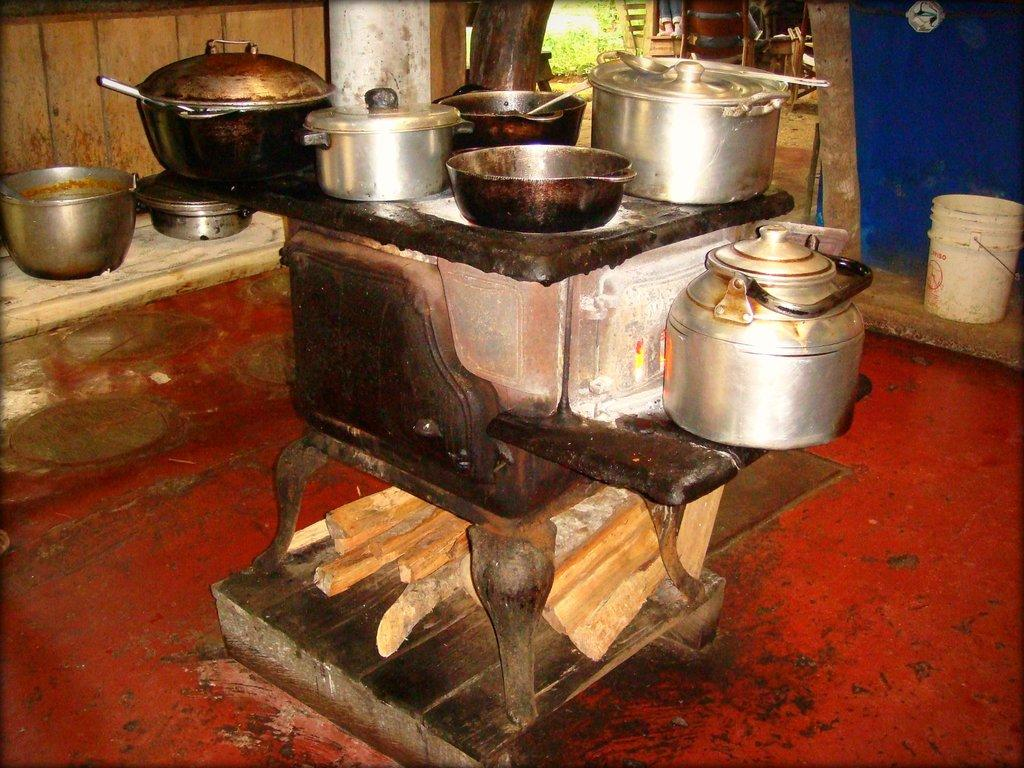What types of objects can be seen in the image? There are many utensils, chairs, sticks, and a bucket in the image. Can you describe the utensils in the image? The utensils in the image are not specified, but they are present in large numbers. What are the chairs used for in the image? The chairs are likely used for seating, but their specific purpose is not mentioned. What is the purpose of the sticks in the image? The purpose of the sticks in the image is not mentioned, but they are present. What is the bucket used for in the image? The purpose of the bucket in the image is not mentioned, but it is present. Can you describe the butter on the chairs in the image? There is no butter present in the image; it only features utensils, chairs, sticks, and a bucket. 